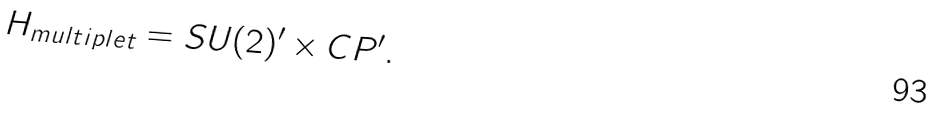Convert formula to latex. <formula><loc_0><loc_0><loc_500><loc_500>H _ { m u l t i p l e t } = S U ( 2 ) ^ { \prime } \times C P ^ { \prime } .</formula> 